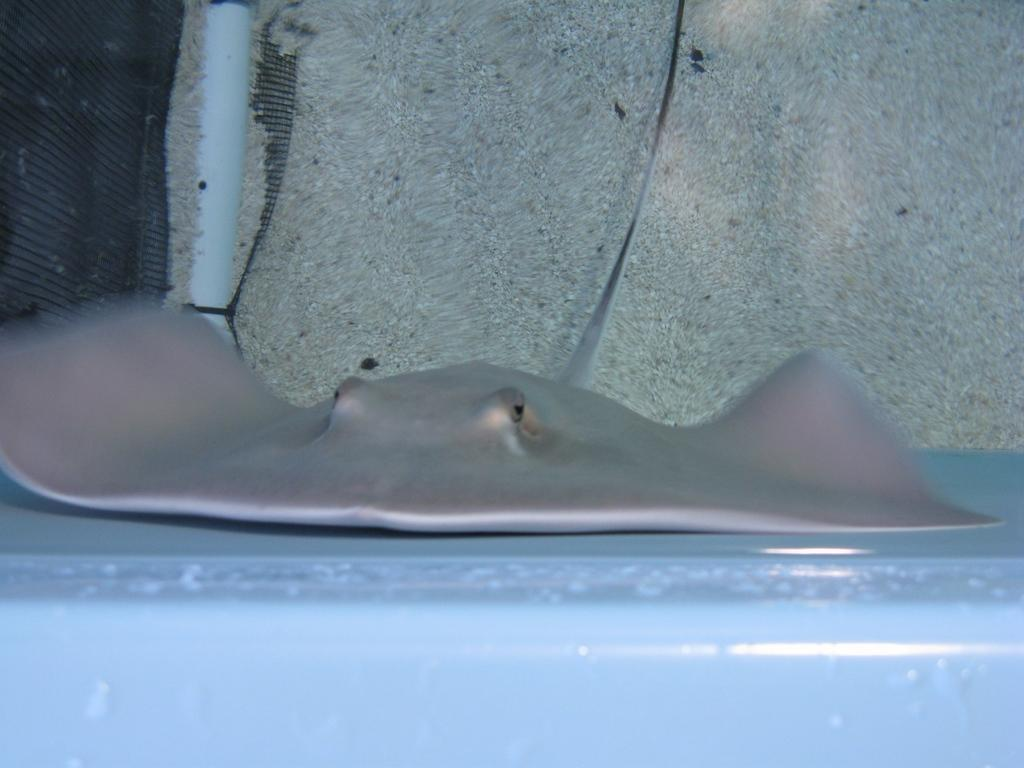What is the main subject in the center of the image? There is a stingray in the center of the image. What can be seen in the background of the image? There is a wall and a mesh present in the background of the image. What type of curtain is hanging from the wall in the image? There is no curtain present in the image; only a wall and a mesh are visible in the background. 